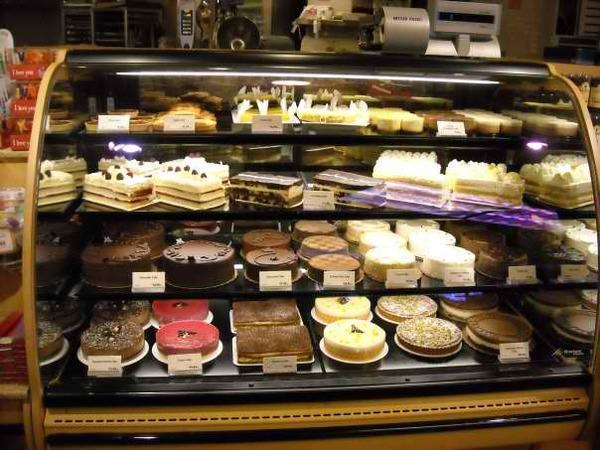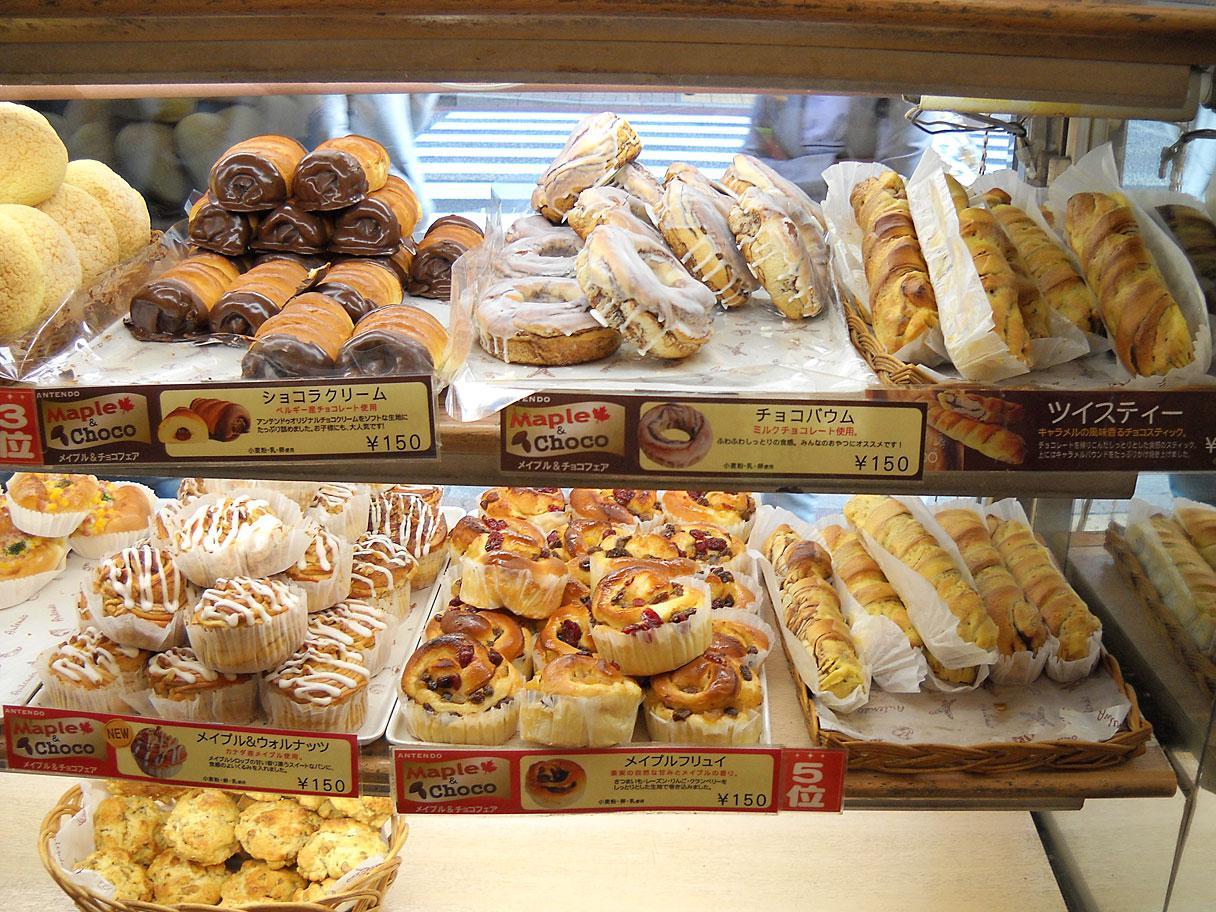The first image is the image on the left, the second image is the image on the right. Given the left and right images, does the statement "the items in the image on the left are in a class case" hold true? Answer yes or no. Yes. The first image is the image on the left, the second image is the image on the right. For the images shown, is this caption "The labels are handwritten in one of the images." true? Answer yes or no. No. 